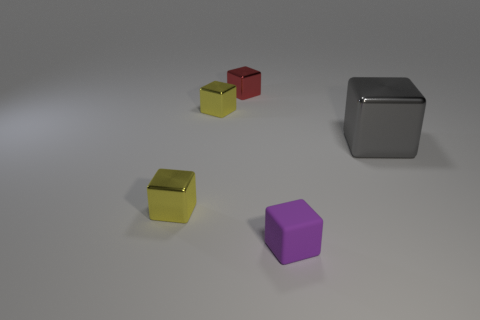Subtract 2 blocks. How many blocks are left? 3 Subtract all large gray blocks. How many blocks are left? 4 Subtract all gray cubes. How many cubes are left? 4 Subtract all green blocks. Subtract all gray cylinders. How many blocks are left? 5 Add 5 tiny metal cubes. How many objects exist? 10 Subtract 0 brown spheres. How many objects are left? 5 Subtract all tiny yellow things. Subtract all gray shiny things. How many objects are left? 2 Add 3 metal things. How many metal things are left? 7 Add 4 green objects. How many green objects exist? 4 